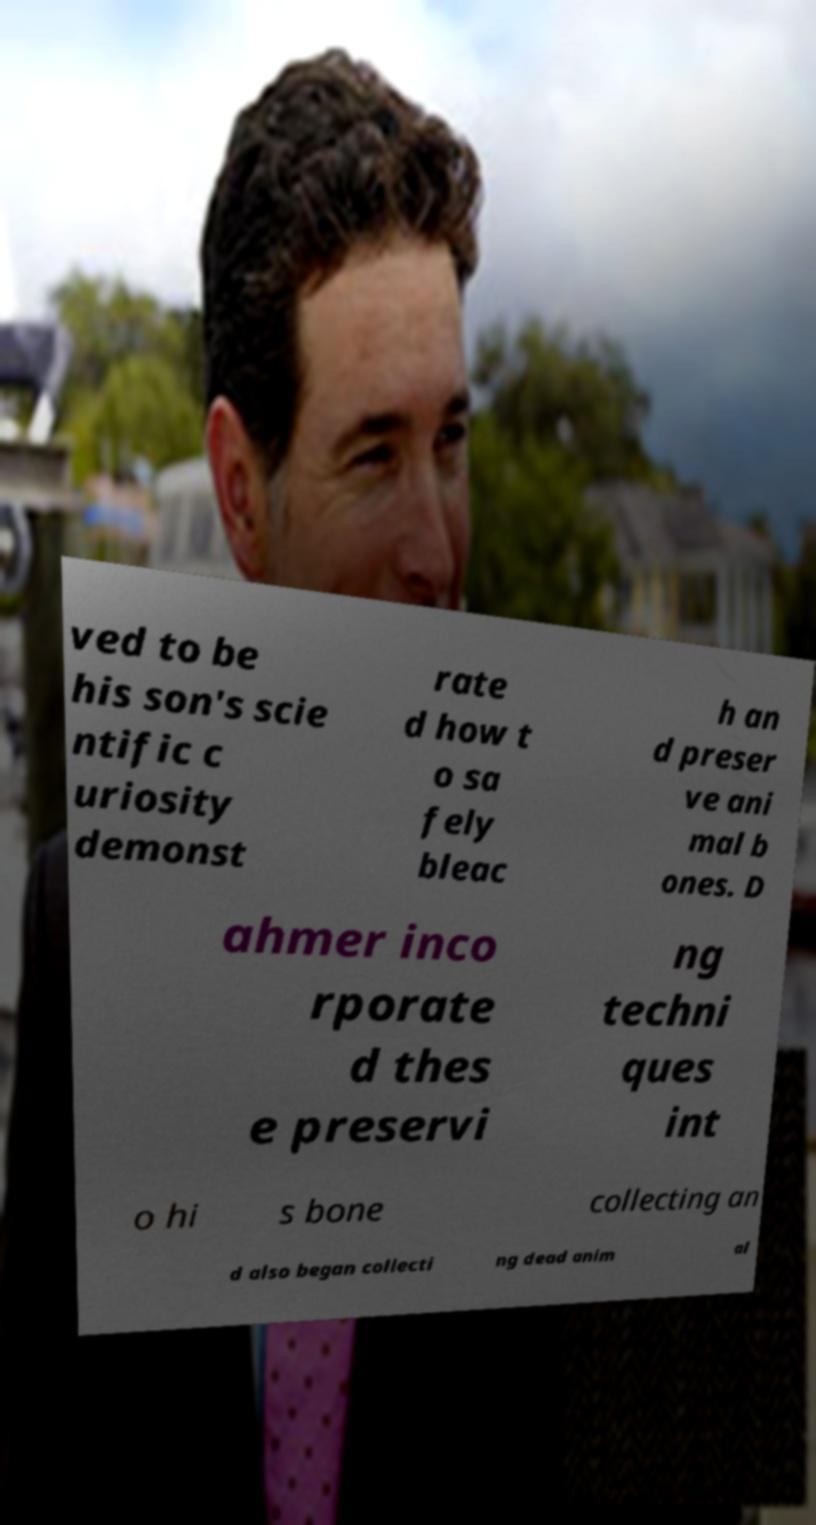I need the written content from this picture converted into text. Can you do that? ved to be his son's scie ntific c uriosity demonst rate d how t o sa fely bleac h an d preser ve ani mal b ones. D ahmer inco rporate d thes e preservi ng techni ques int o hi s bone collecting an d also began collecti ng dead anim al 